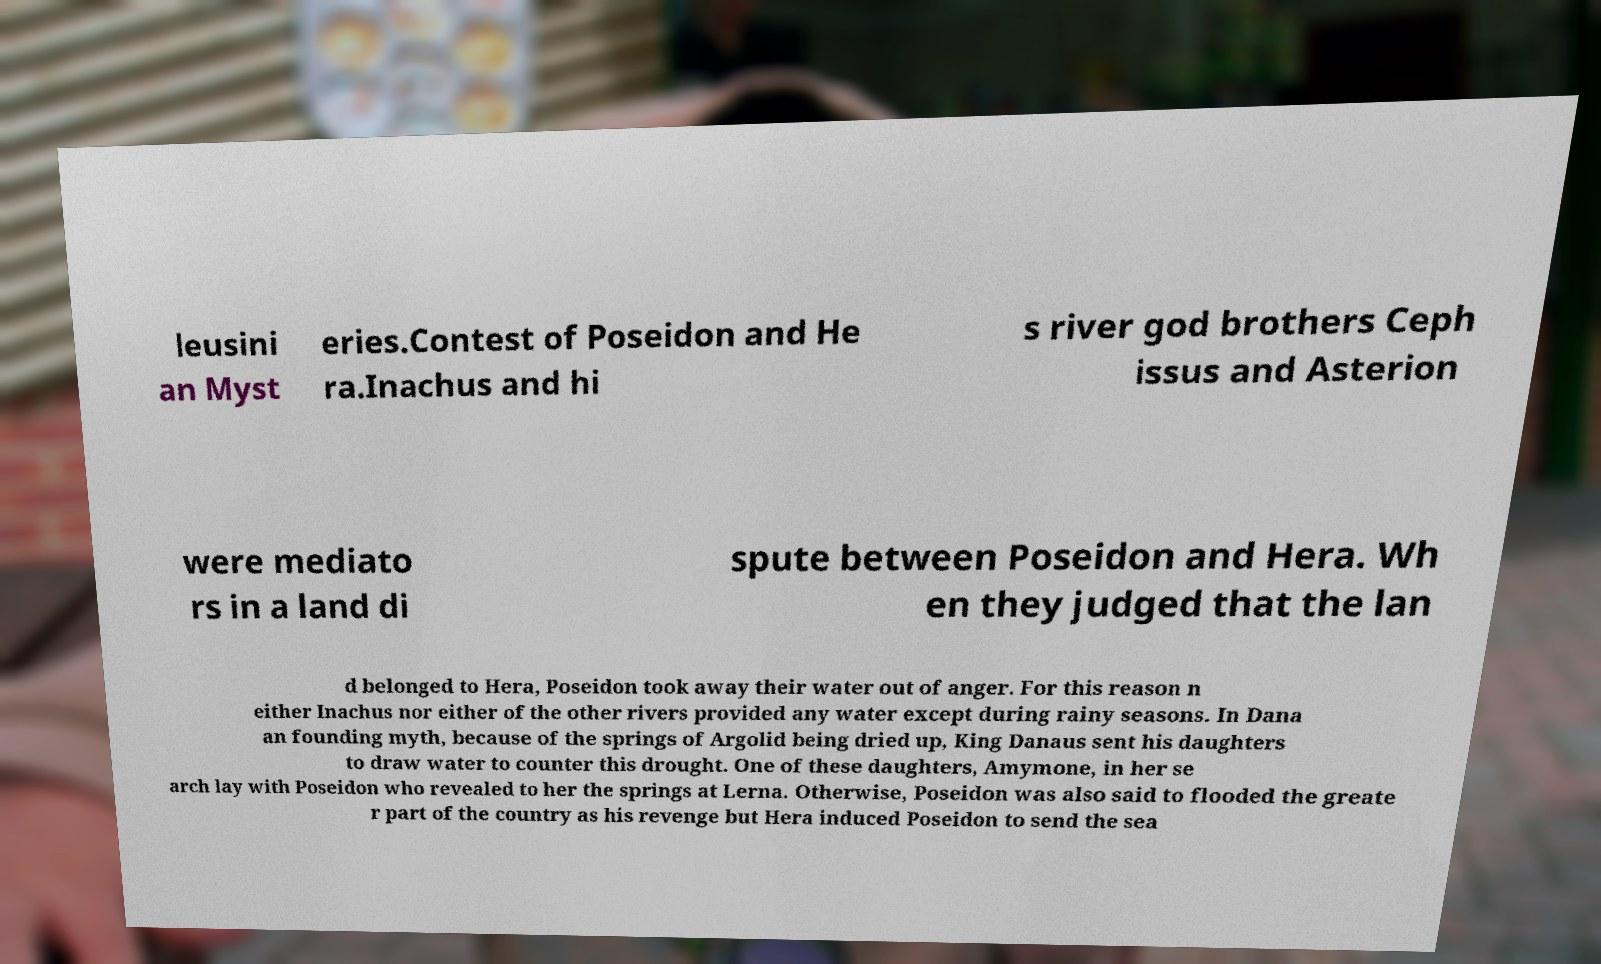Can you read and provide the text displayed in the image?This photo seems to have some interesting text. Can you extract and type it out for me? leusini an Myst eries.Contest of Poseidon and He ra.Inachus and hi s river god brothers Ceph issus and Asterion were mediato rs in a land di spute between Poseidon and Hera. Wh en they judged that the lan d belonged to Hera, Poseidon took away their water out of anger. For this reason n either Inachus nor either of the other rivers provided any water except during rainy seasons. In Dana an founding myth, because of the springs of Argolid being dried up, King Danaus sent his daughters to draw water to counter this drought. One of these daughters, Amymone, in her se arch lay with Poseidon who revealed to her the springs at Lerna. Otherwise, Poseidon was also said to flooded the greate r part of the country as his revenge but Hera induced Poseidon to send the sea 